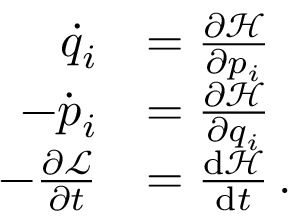Convert formula to latex. <formula><loc_0><loc_0><loc_500><loc_500>{ \begin{array} { r l } { { \dot { q } } _ { i } } & { = { \frac { \partial { \mathcal { H } } } { \partial p _ { i } } } } \\ { - { \dot { p } } _ { i } } & { = { \frac { \partial { \mathcal { H } } } { \partial q _ { i } } } } \\ { - { \frac { \partial { \mathcal { L } } } { \partial t } } } & { = { \frac { { d } { \mathcal { H } } } { { d } t } } \, . } \end{array} }</formula> 